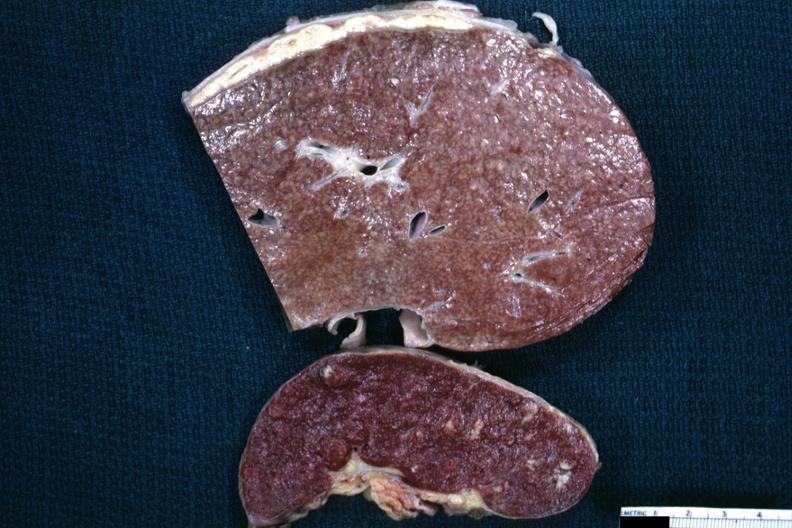what is present?
Answer the question using a single word or phrase. Peritoneum 